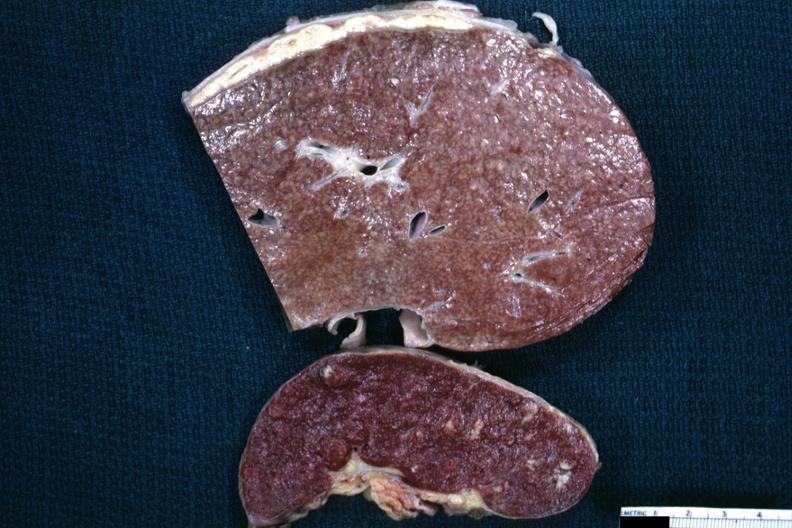what is present?
Answer the question using a single word or phrase. Peritoneum 